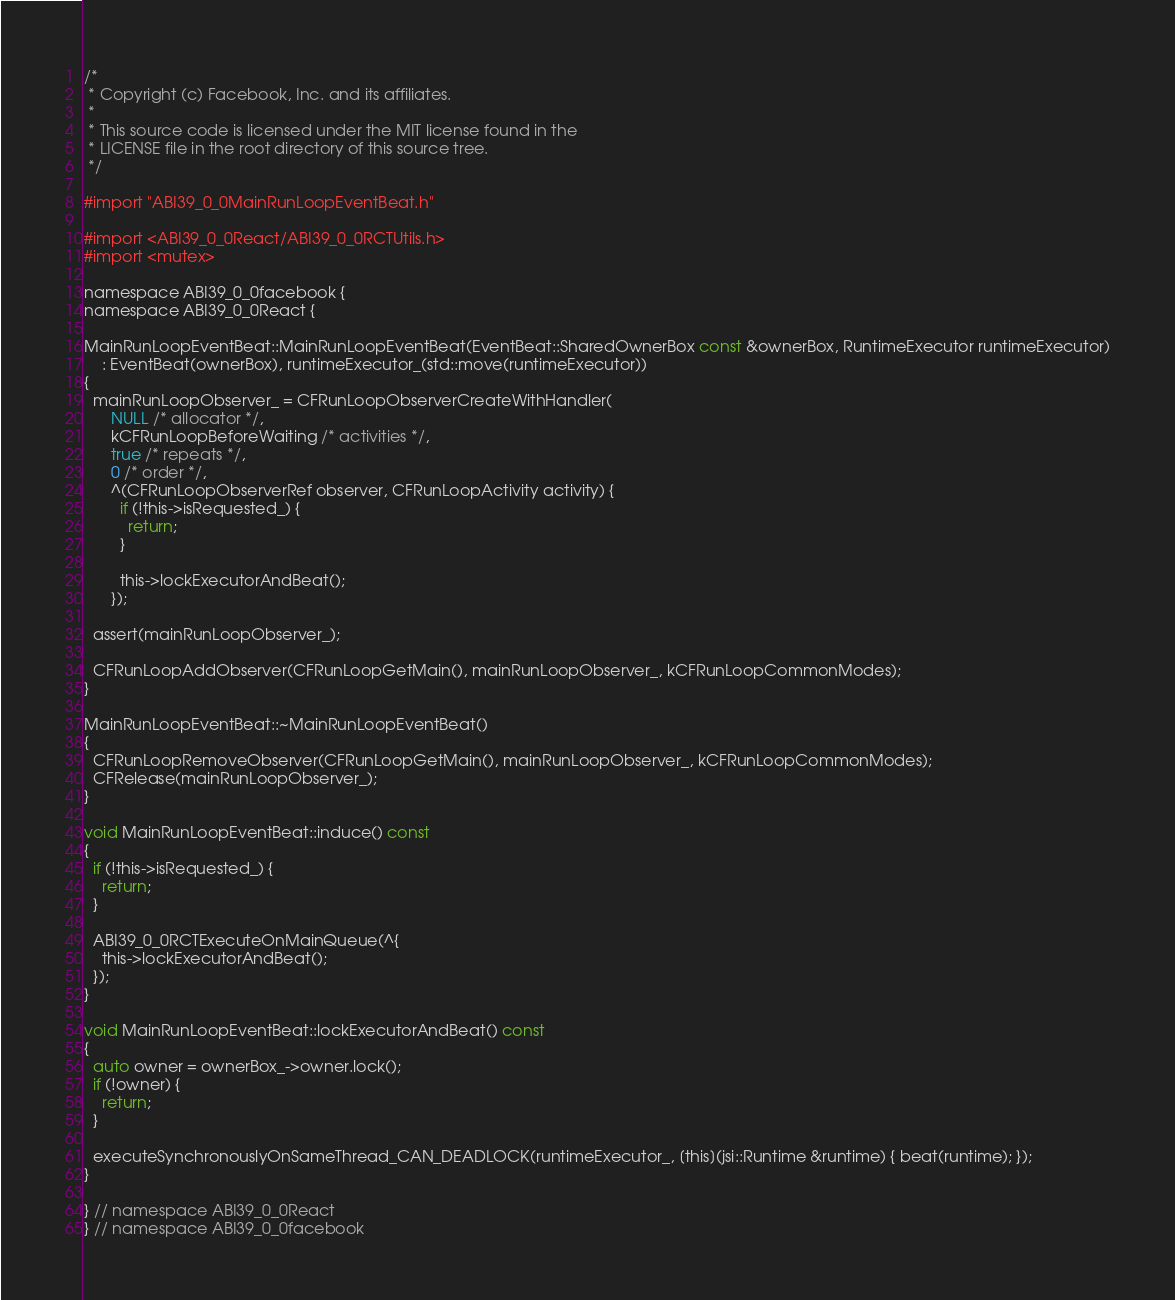Convert code to text. <code><loc_0><loc_0><loc_500><loc_500><_ObjectiveC_>/*
 * Copyright (c) Facebook, Inc. and its affiliates.
 *
 * This source code is licensed under the MIT license found in the
 * LICENSE file in the root directory of this source tree.
 */

#import "ABI39_0_0MainRunLoopEventBeat.h"

#import <ABI39_0_0React/ABI39_0_0RCTUtils.h>
#import <mutex>

namespace ABI39_0_0facebook {
namespace ABI39_0_0React {

MainRunLoopEventBeat::MainRunLoopEventBeat(EventBeat::SharedOwnerBox const &ownerBox, RuntimeExecutor runtimeExecutor)
    : EventBeat(ownerBox), runtimeExecutor_(std::move(runtimeExecutor))
{
  mainRunLoopObserver_ = CFRunLoopObserverCreateWithHandler(
      NULL /* allocator */,
      kCFRunLoopBeforeWaiting /* activities */,
      true /* repeats */,
      0 /* order */,
      ^(CFRunLoopObserverRef observer, CFRunLoopActivity activity) {
        if (!this->isRequested_) {
          return;
        }

        this->lockExecutorAndBeat();
      });

  assert(mainRunLoopObserver_);

  CFRunLoopAddObserver(CFRunLoopGetMain(), mainRunLoopObserver_, kCFRunLoopCommonModes);
}

MainRunLoopEventBeat::~MainRunLoopEventBeat()
{
  CFRunLoopRemoveObserver(CFRunLoopGetMain(), mainRunLoopObserver_, kCFRunLoopCommonModes);
  CFRelease(mainRunLoopObserver_);
}

void MainRunLoopEventBeat::induce() const
{
  if (!this->isRequested_) {
    return;
  }

  ABI39_0_0RCTExecuteOnMainQueue(^{
    this->lockExecutorAndBeat();
  });
}

void MainRunLoopEventBeat::lockExecutorAndBeat() const
{
  auto owner = ownerBox_->owner.lock();
  if (!owner) {
    return;
  }

  executeSynchronouslyOnSameThread_CAN_DEADLOCK(runtimeExecutor_, [this](jsi::Runtime &runtime) { beat(runtime); });
}

} // namespace ABI39_0_0React
} // namespace ABI39_0_0facebook
</code> 